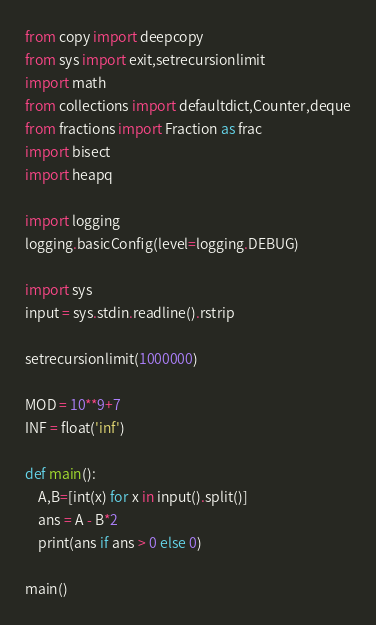Convert code to text. <code><loc_0><loc_0><loc_500><loc_500><_Python_>from copy import deepcopy
from sys import exit,setrecursionlimit
import math
from collections import defaultdict,Counter,deque
from fractions import Fraction as frac
import bisect
import heapq

import logging
logging.basicConfig(level=logging.DEBUG)

import sys
input = sys.stdin.readline().rstrip

setrecursionlimit(1000000)

MOD = 10**9+7
INF = float('inf')

def main():
    A,B=[int(x) for x in input().split()]
    ans = A - B*2
    print(ans if ans > 0 else 0)

main()</code> 